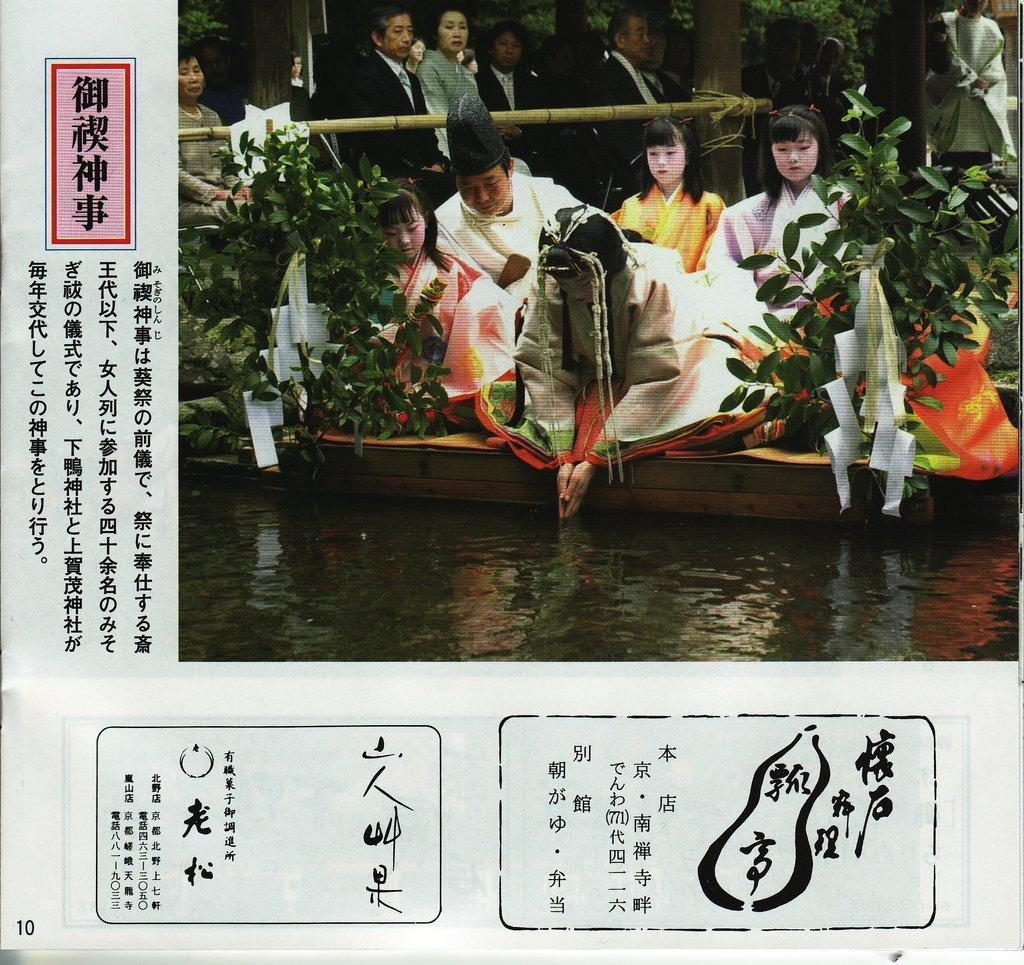How many people are in the image? There is a group of people in the image, but the exact number cannot be determined from the provided facts. What is the primary setting of the image? The image features water and plants, suggesting a natural environment. Can you describe the people in the image? The provided facts do not give any specific details about the people in the image. What type of coat is the cat wearing in the image? There is no cat present in the image, and therefore no coat can be observed. 